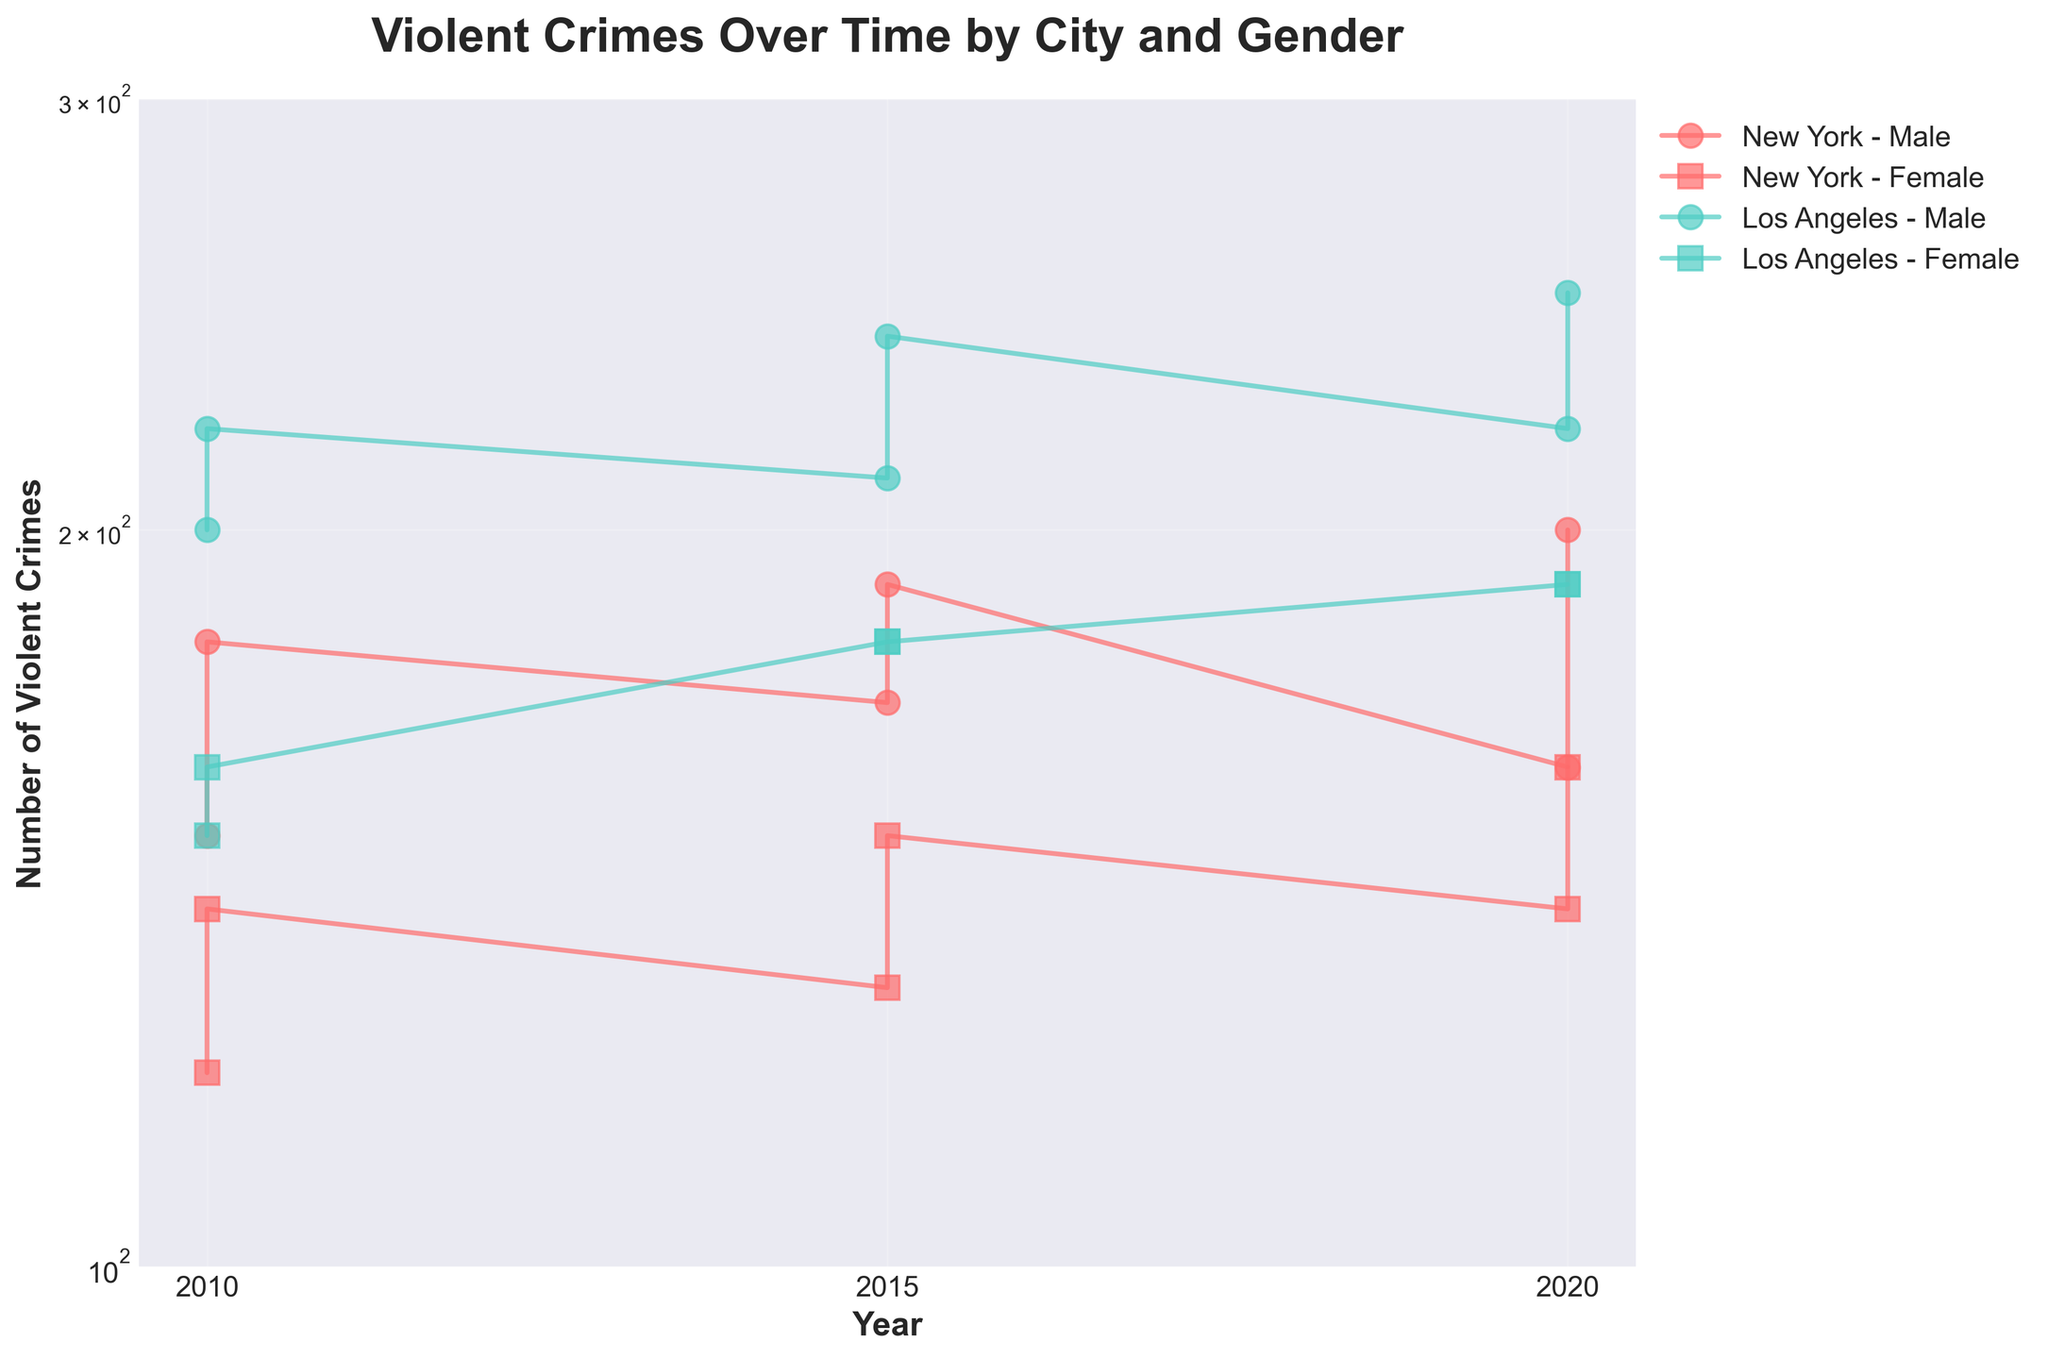What is the title of the figure? The title is displayed at the top of the figure. It is typically bold and descriptive, summarizing the main content of the plot. Here, it reads, "Violent Crimes Over Time by City and Gender."
Answer: Violent Crimes Over Time by City and Gender Which city had more violent crimes reported in 2010 for males? To determine this, look at the data points for males in 2010 for both cities. Compare the values: New York's males had 150 and Los Angeles's males had 200.
Answer: Los Angeles What is the overall trend in violent crimes for females in New York from 2010 to 2020? Observe the data points for New York females across the years. The values are 120 (2010), 130 (2015), and 140 (2020). This shows a gradually increasing trend.
Answer: Increasing How did the number of violent crimes reported for 26-35 year old males in Los Angeles change from 2010 to 2020? Look at the plot points for Los Angeles males aged 26-35 in 2010, 2015, and 2020. The values are 220 (2010), 240 (2015), and 250 (2020), indicating a consistent increase over these years.
Answer: Increased Compare the number of violent crimes in 2015 between males and females in Los Angeles. Examine the data points in 2015 for males and females in Los Angeles: 210 for males and 180 for females. Since 210 > 180, males reported more violent crimes.
Answer: Males had more What is the percentage increase in violent crimes for females in Los Angeles from 2010 to 2020? In 2010, the value is 150, and in 2020, it's 190. Calculate the percentage increase: ((190 - 150) / 150) * 100% = 26.67%.
Answer: 26.67% Compare the violent crime trends for males in New York and Los Angeles. Analyze the trend lines for males in both cities. For New York, crime numbers slightly increase from 150 (2010) to 160 (2020), whereas for Los Angeles, they increased more significantly from 200 (2010) to 220 (2020).
Answer: Los Angeles' rate increased more Which city and gender combination has the highest number of violent crimes in any year, and what is that number? Look for the peak value among all plotted points, which is 250 for males in Los Angeles in 2020.
Answer: Los Angeles males in 2020 with 250 How does using a log scale affect the visualization of violent crime trends? A log scale compresses the range of values, making it easier to compare rates of change between small and large values. It makes trends appear less steep and highlights proportional changes.
Answer: Compresses and highlights proportional changes 